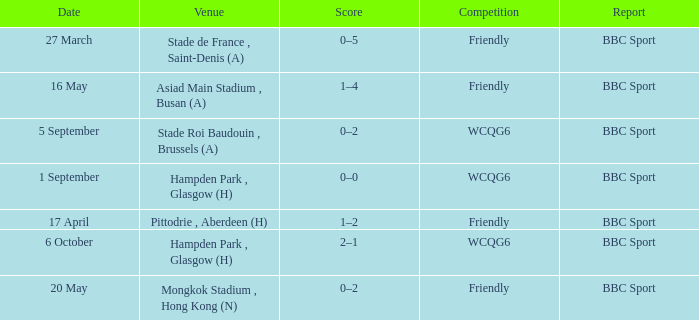Who reported the game on 6 october? BBC Sport. Can you parse all the data within this table? {'header': ['Date', 'Venue', 'Score', 'Competition', 'Report'], 'rows': [['27 March', 'Stade de France , Saint-Denis (A)', '0–5', 'Friendly', 'BBC Sport'], ['16 May', 'Asiad Main Stadium , Busan (A)', '1–4', 'Friendly', 'BBC Sport'], ['5 September', 'Stade Roi Baudouin , Brussels (A)', '0–2', 'WCQG6', 'BBC Sport'], ['1 September', 'Hampden Park , Glasgow (H)', '0–0', 'WCQG6', 'BBC Sport'], ['17 April', 'Pittodrie , Aberdeen (H)', '1–2', 'Friendly', 'BBC Sport'], ['6 October', 'Hampden Park , Glasgow (H)', '2–1', 'WCQG6', 'BBC Sport'], ['20 May', 'Mongkok Stadium , Hong Kong (N)', '0–2', 'Friendly', 'BBC Sport']]} 